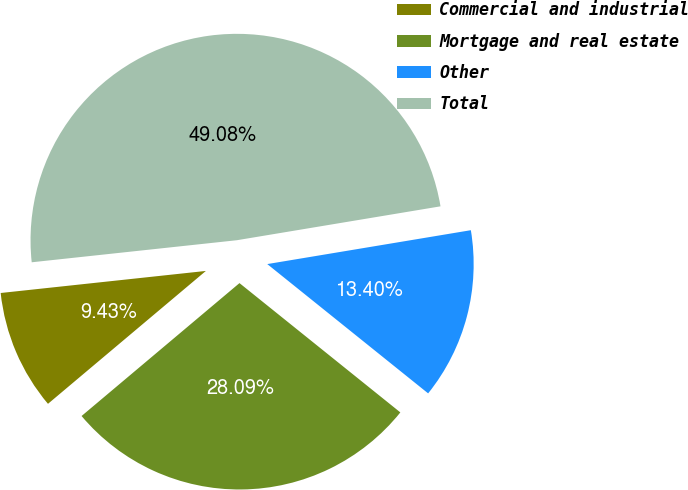<chart> <loc_0><loc_0><loc_500><loc_500><pie_chart><fcel>Commercial and industrial<fcel>Mortgage and real estate<fcel>Other<fcel>Total<nl><fcel>9.43%<fcel>28.09%<fcel>13.4%<fcel>49.08%<nl></chart> 